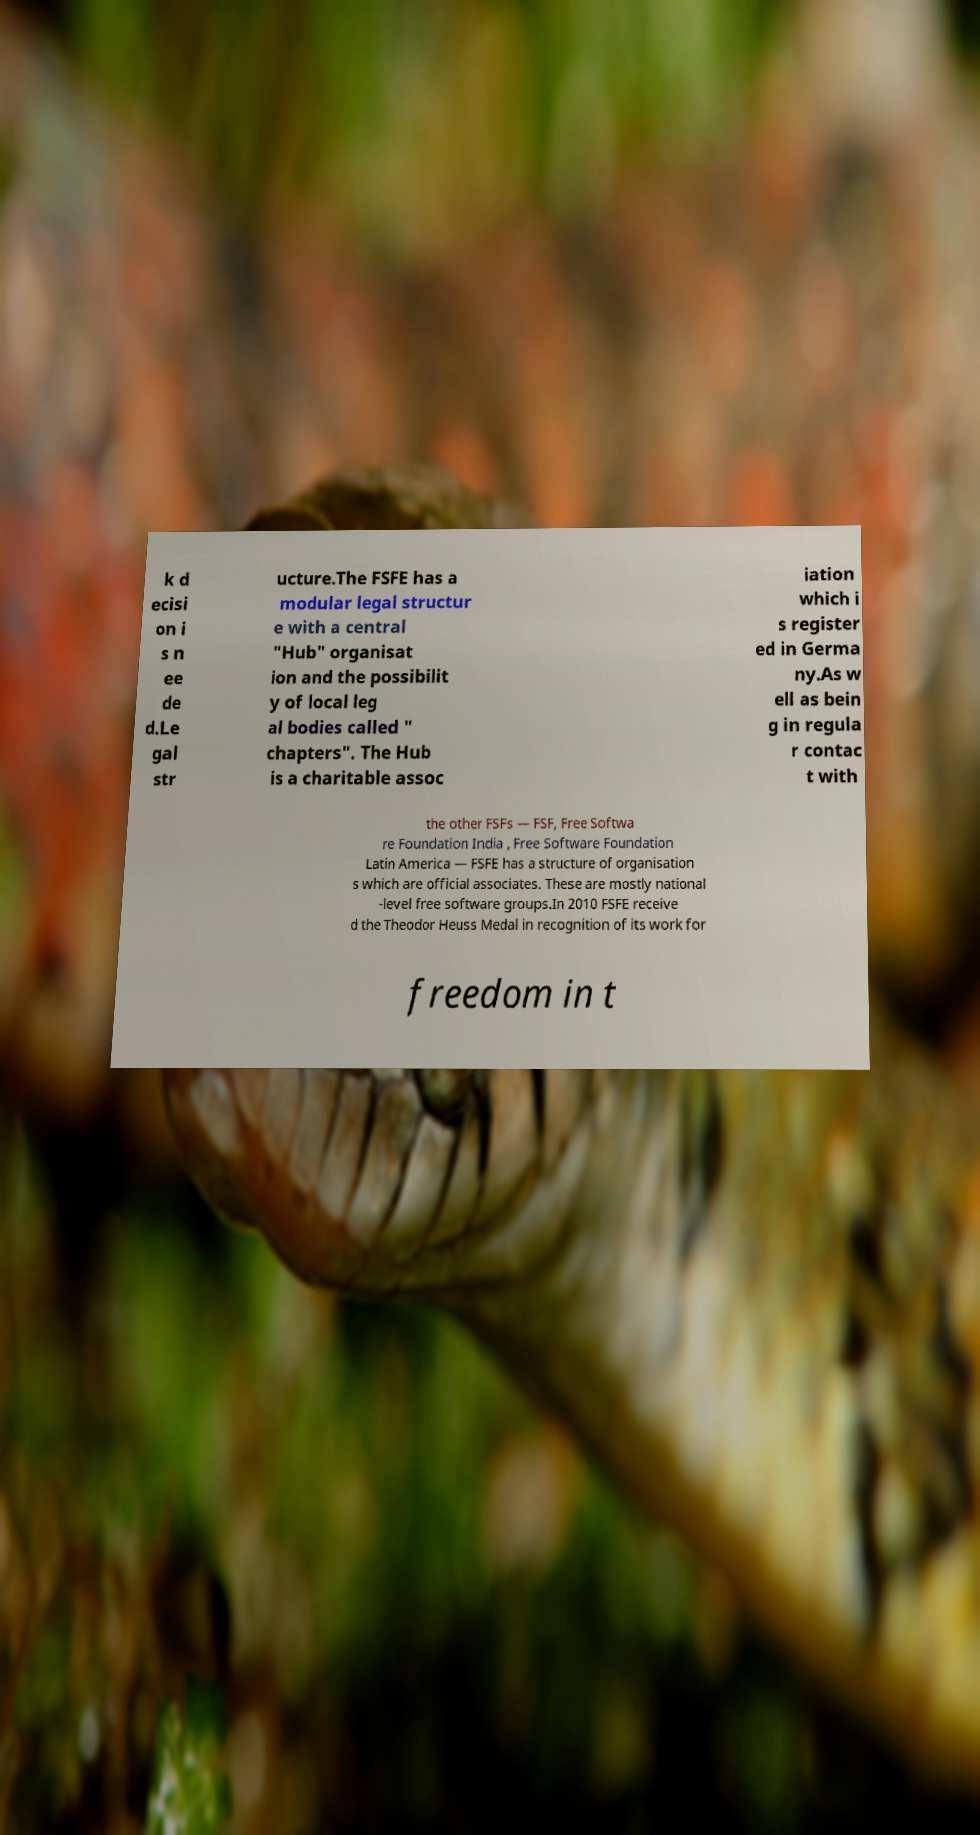Please read and relay the text visible in this image. What does it say? k d ecisi on i s n ee de d.Le gal str ucture.The FSFE has a modular legal structur e with a central "Hub" organisat ion and the possibilit y of local leg al bodies called " chapters". The Hub is a charitable assoc iation which i s register ed in Germa ny.As w ell as bein g in regula r contac t with the other FSFs — FSF, Free Softwa re Foundation India , Free Software Foundation Latin America — FSFE has a structure of organisation s which are official associates. These are mostly national -level free software groups.In 2010 FSFE receive d the Theodor Heuss Medal in recognition of its work for freedom in t 